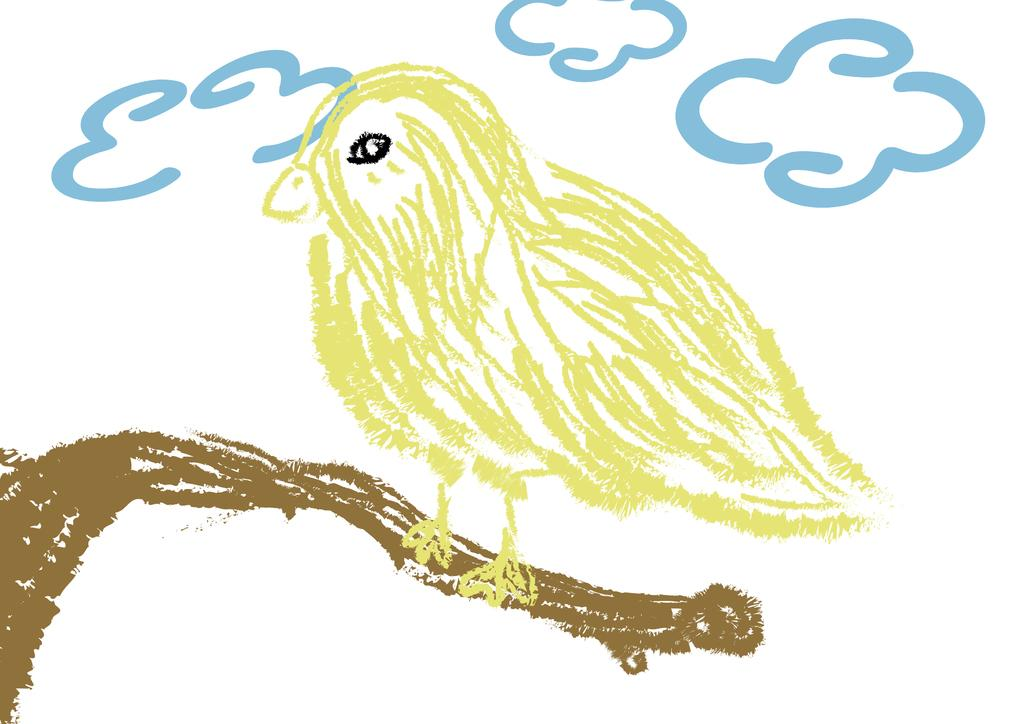What is the main subject of the drawing in the image? There is a drawing of a bird in the image. Where is the bird located in the drawing? The bird is depicted on the branch of a tree. What else can be seen in the sky in the image? There are clouds visible in the image. What type of knife is being used by the bird in the image? There is no knife present in the image; it is a drawing of a bird on a tree branch. 